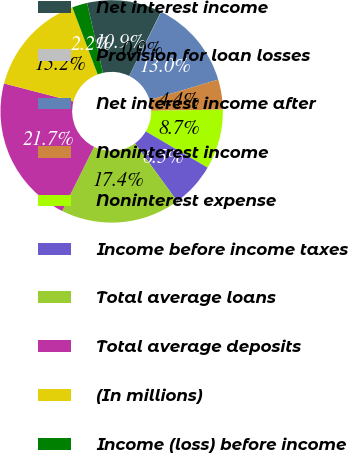<chart> <loc_0><loc_0><loc_500><loc_500><pie_chart><fcel>Net interest income<fcel>Provision for loan losses<fcel>Net interest income after<fcel>Noninterest income<fcel>Noninterest expense<fcel>Income before income taxes<fcel>Total average loans<fcel>Total average deposits<fcel>(In millions)<fcel>Income (loss) before income<nl><fcel>10.87%<fcel>0.03%<fcel>13.03%<fcel>4.36%<fcel>8.7%<fcel>6.53%<fcel>17.37%<fcel>21.7%<fcel>15.2%<fcel>2.2%<nl></chart> 